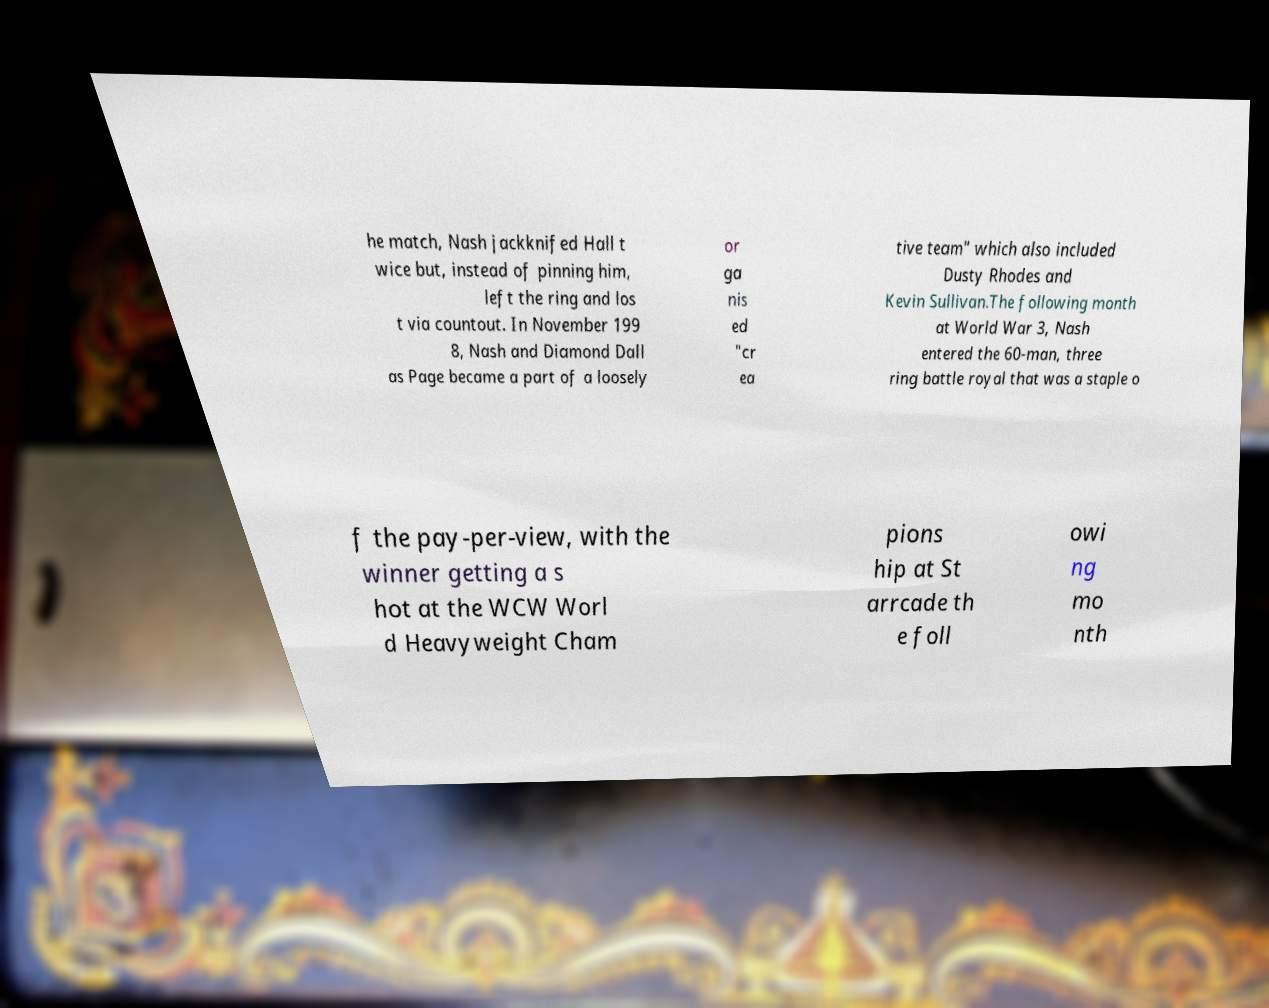Can you accurately transcribe the text from the provided image for me? he match, Nash jackknifed Hall t wice but, instead of pinning him, left the ring and los t via countout. In November 199 8, Nash and Diamond Dall as Page became a part of a loosely or ga nis ed "cr ea tive team" which also included Dusty Rhodes and Kevin Sullivan.The following month at World War 3, Nash entered the 60-man, three ring battle royal that was a staple o f the pay-per-view, with the winner getting a s hot at the WCW Worl d Heavyweight Cham pions hip at St arrcade th e foll owi ng mo nth 